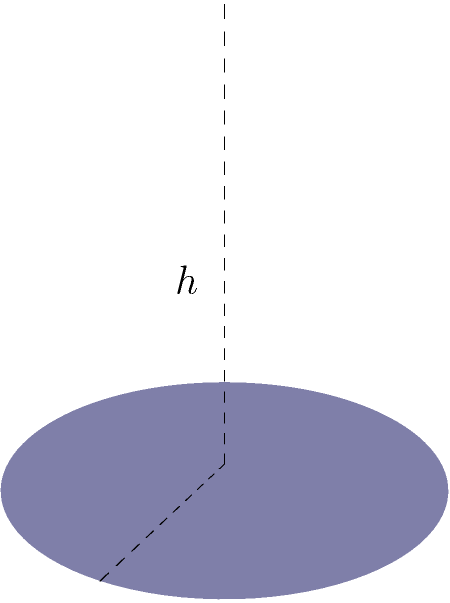As an innovative tea mixologist, you've designed a unique cone-shaped tea infuser. The infuser has a height of 4 cm and a base radius of 2 cm. Calculate the volume of tea this infuser can hold, rounded to the nearest 0.1 cm³. To calculate the volume of a cone-shaped tea infuser, we'll use the formula for the volume of a cone:

$$V = \frac{1}{3}\pi r^2 h$$

Where:
$V$ = volume
$r$ = radius of the base
$h$ = height of the cone

Given:
$r = 2$ cm
$h = 4$ cm

Let's substitute these values into the formula:

$$V = \frac{1}{3}\pi (2\text{ cm})^2 (4\text{ cm})$$

$$V = \frac{1}{3}\pi (4\text{ cm}^2) (4\text{ cm})$$

$$V = \frac{16}{3}\pi\text{ cm}^3$$

Now, let's calculate this value:

$$V \approx 16.755\text{ cm}^3$$

Rounding to the nearest 0.1 cm³:

$$V \approx 16.8\text{ cm}^3$$
Answer: 16.8 cm³ 